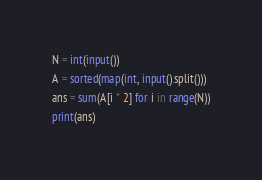Convert code to text. <code><loc_0><loc_0><loc_500><loc_500><_Python_>N = int(input())
A = sorted(map(int, input().split()))
ans = sum(A[i * 2] for i in range(N))
print(ans)
</code> 